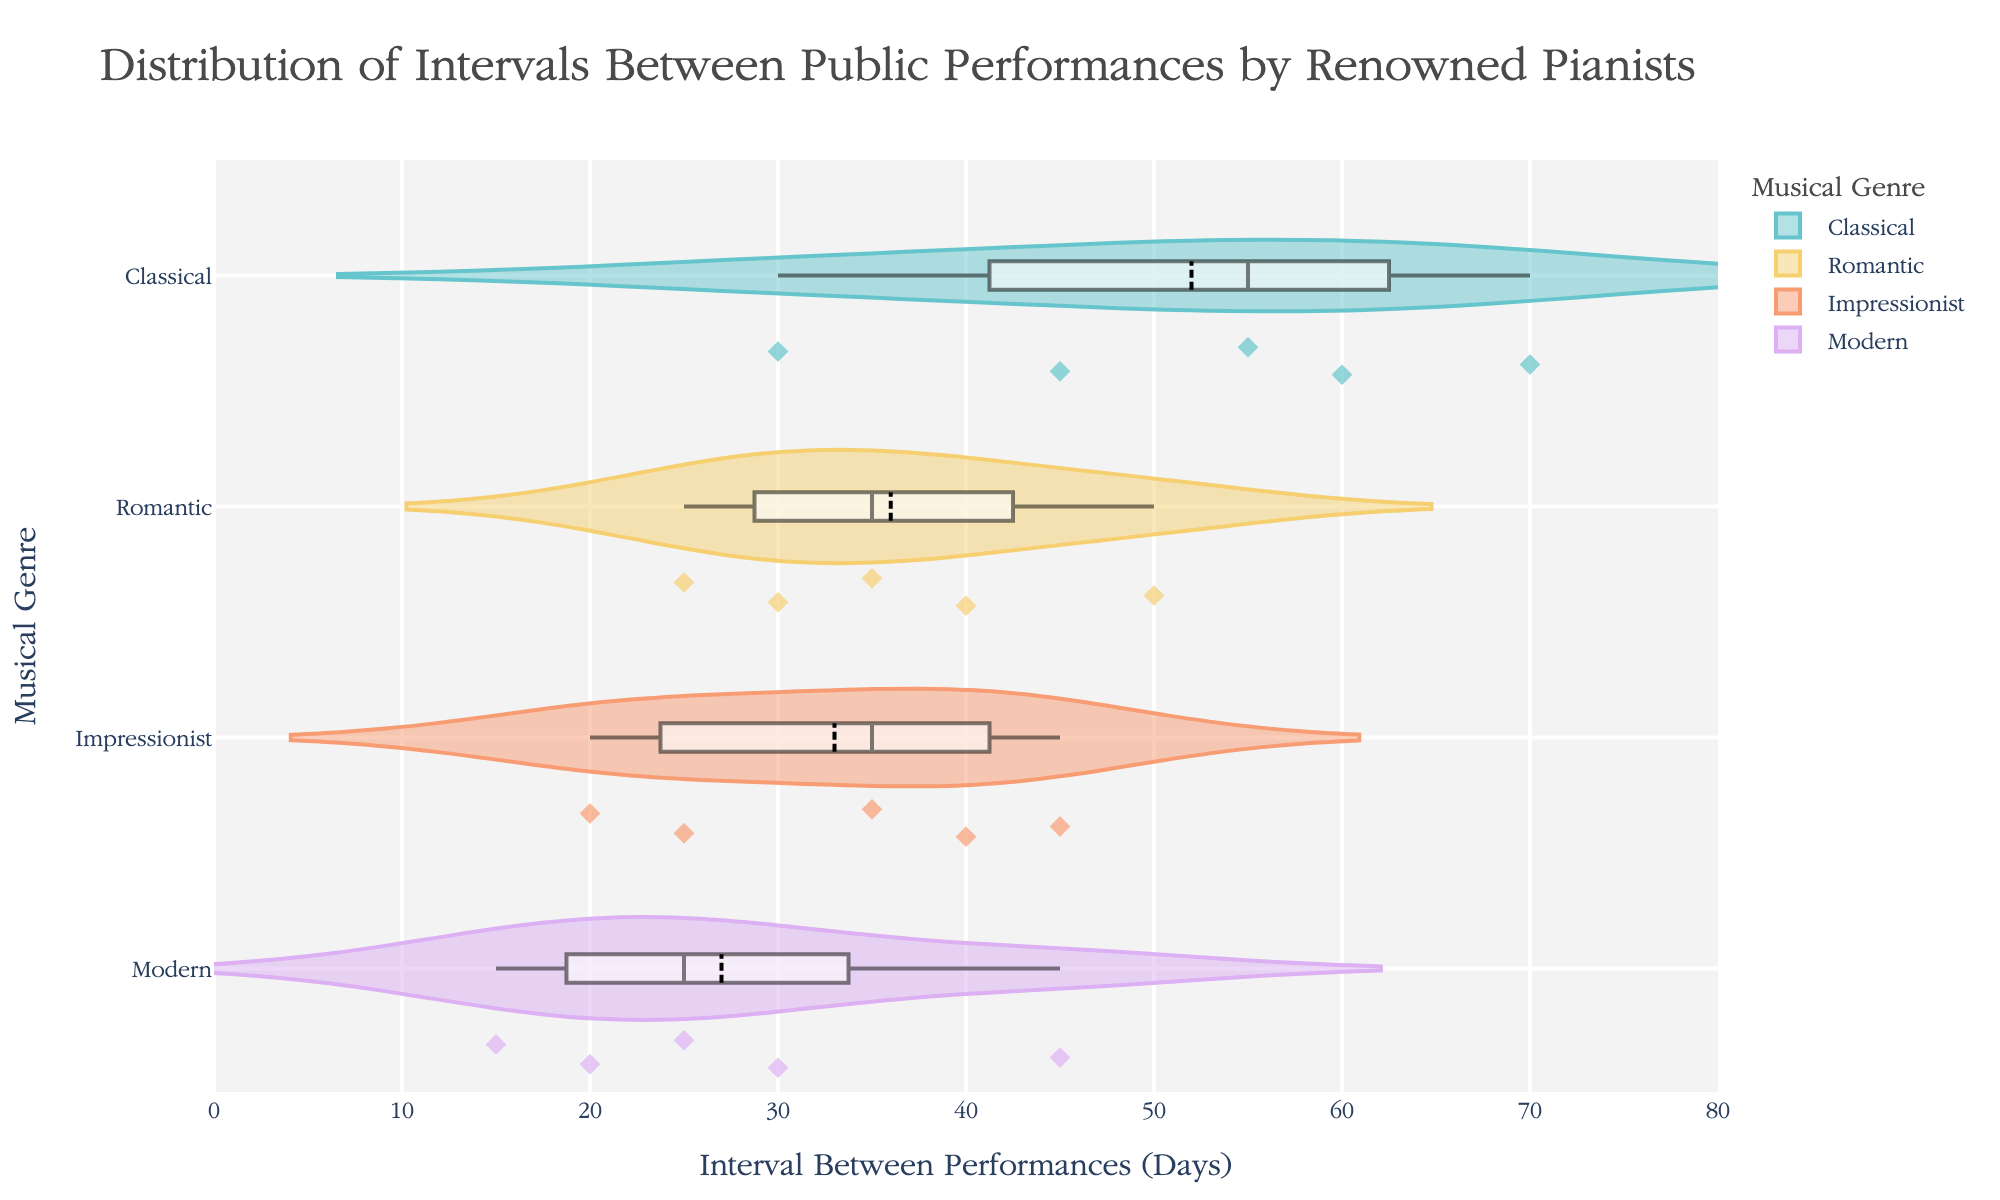What is the title of the plot? The title of a plot is prominently displayed at the top and summarizes the content.
Answer: Distribution of Intervals Between Public Performances by Renowned Pianists Which genre has the shortest median interval between performances? Look at each genre's median line within the violin plot, which is usually marked by a thicker line. The genre with the shortest median can be identified from this feature.
Answer: Modern What is the range of intervals for Classical pianists? By examining the horizontal axis (Interval Between Performances in Days) and the spread of the Classical genre's violin plot, determine the minimum and maximum values.
Answer: 30 to 70 days Which genres have outliers, and who are those outliers? Check for any individual data points that fall noticeably outside of the main distribution for each genre. These outliers will often be marked distinctively.
Answer: Classical (Mitsuko Uchida, Murray Perahia), Romantic (Stephen Hough), Impressionist (Xavier de Maistre) How do the intervals compare between Romantic and Impressionist pianists overall? Compare the shapes, spreads, and positions of the violin plots for Romantic and Impressionist genres. Notice the range, density, and any outliers.
Answer: Romantic has a wider range; Impressionist has slightly shorter intervals overall Which genre has the least variability in intervals? Identify the genre with the tightest, least spread out violin plot. This genre has less variability in performance intervals.
Answer: Modern What is the average interval between performances for Modern pianists? Locate the mean lines for the Modern genre and average these values if they are not already marked with another feature on the plot.
Answer: Approximately 27.5 days Is there any overlap in the intervals between Classical and Romantic pianists? Look at the horizontal positioning of the violin plots for Classical and Romantic genres. Identify if there’s any range where data points from both genres coincide.
Answer: Yes, between 30 to 50 days Which genre has the highest number of individual data points? Count or estimate the number of individual markers or points within each genre’s violin plot. The genre with the highest count will be the answer.
Answer: Romantic What are the performance intervals for Daniil Trifonov and Jean-Yves Thibaudet? Find the data points within their respective genres, Modern for Daniil Trifonov and Impressionist for Jean-Yves Thibaudet. The interval will be indicated by the position on the horizontal axis.
Answer: 25 days (Daniil Trifonov), 20 days (Jean-Yves Thibaudet) 